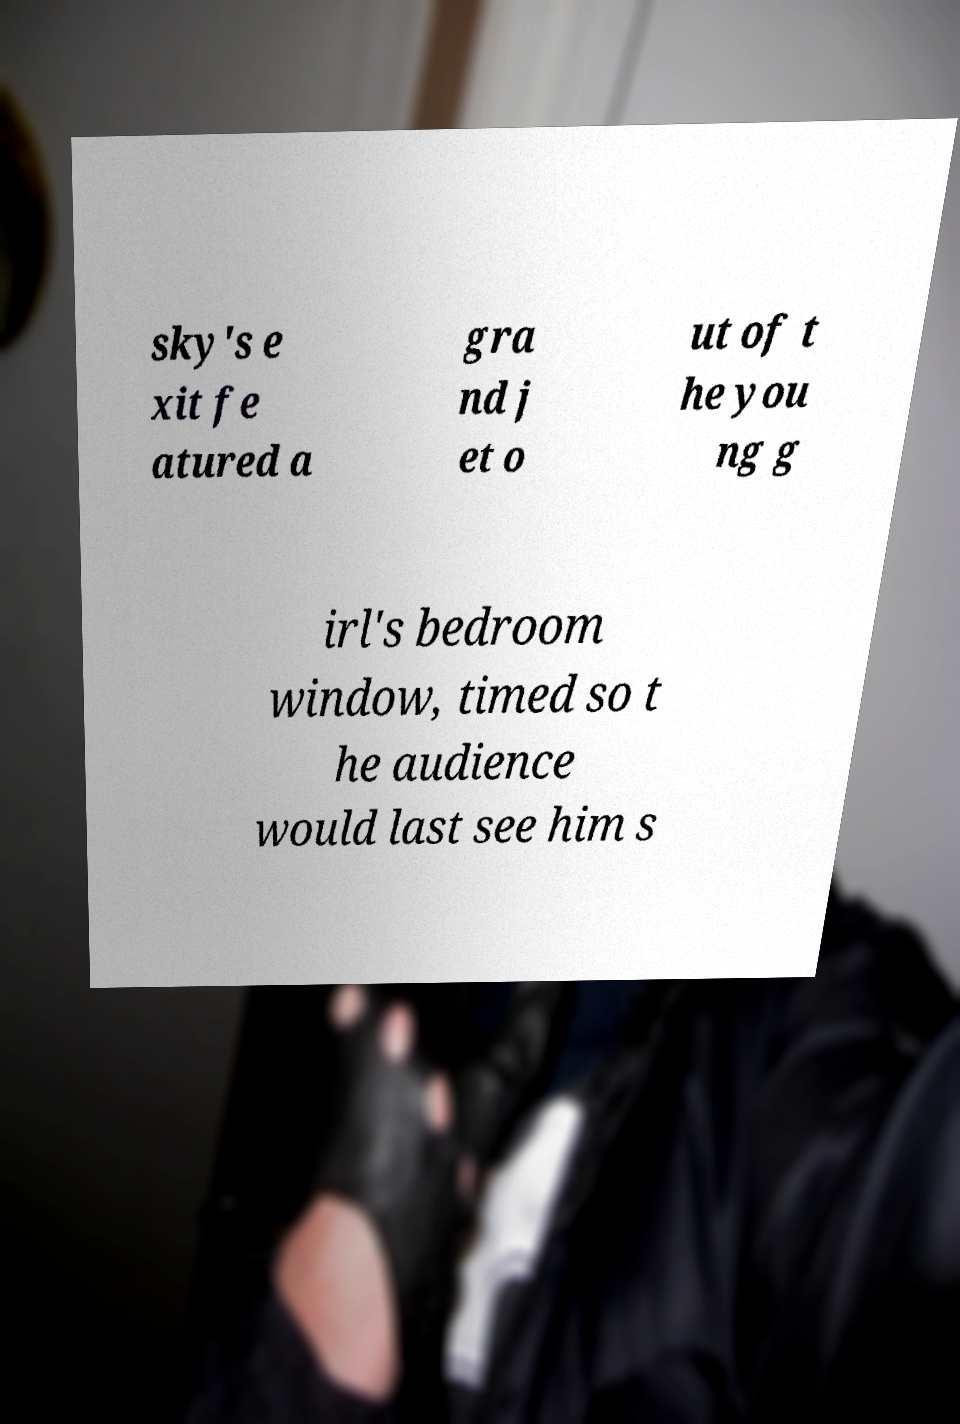Can you read and provide the text displayed in the image?This photo seems to have some interesting text. Can you extract and type it out for me? sky's e xit fe atured a gra nd j et o ut of t he you ng g irl's bedroom window, timed so t he audience would last see him s 